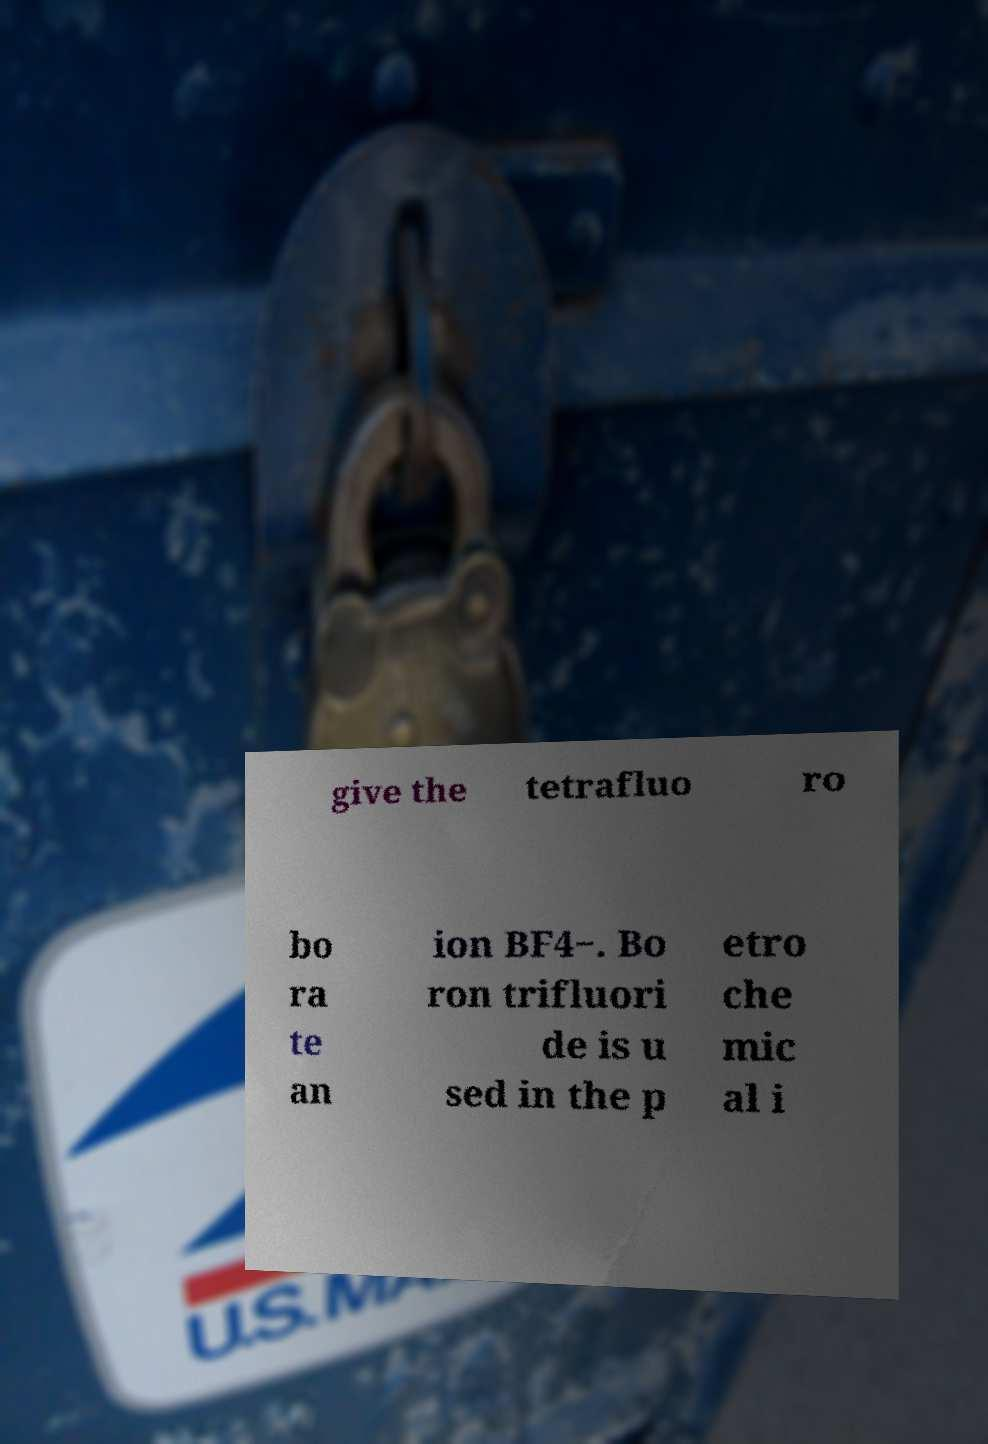I need the written content from this picture converted into text. Can you do that? give the tetrafluo ro bo ra te an ion BF4−. Bo ron trifluori de is u sed in the p etro che mic al i 